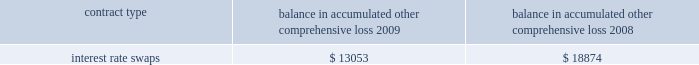The table below represents unrealized losses related to derivative amounts included in 201caccumulated other comprehensive loss 201d for the years ended december 31 , ( in thousands ) : balance in accumulated other comprehensive loss .
Note 9 2013 fair value measurements the company uses the fair value hierarchy , which prioritizes the inputs used to measure the fair value of certain of its financial instruments .
The hierarchy gives the highest priority to unadjusted quoted prices in active markets for identical assets or liabilities ( level 1 measurement ) and the lowest priority to unobservable inputs ( level 3 measurement ) .
The three levels of the fair value hierarchy are set forth below : 2022 level 1 2013 quoted prices are available in active markets for identical assets or liabilities as of the reporting date .
Active markets are those in which transactions for the asset or liability occur in sufficient frequency and volume to provide pricing information on an ongoing basis .
2022 level 2 2013 pricing inputs are other than quoted prices in active markets included in level 1 , which are either directly or indirectly observable as of the reporting date .
Level 2 includes those financial instruments that are valued using models or other valuation methodologies .
These models are primarily industry-standard models that consider various assumptions , including time value , volatility factors , and current market and contractual prices for the underlying instruments , as well as other relevant economic measures .
Substantially all of these assumptions are observable in the marketplace throughout the full term of the instrument , can be derived from observable data or are supported by observable levels at which transactions are executed in the marketplace .
2022 level 3 2013 pricing inputs include significant inputs that are generally less observable from objective sources .
These inputs may be used with internally developed methodologies that result in management 2019s best estimate of fair value from the perspective of a market participant .
The fair value of the interest rate swap transactions are based on the discounted net present value of the swap using third party quotes ( level 2 ) .
Changes in fair market value are recorded in other comprehensive income ( loss ) , and changes resulting from ineffectiveness are recorded in current earnings .
Assets and liabilities measured at fair value are based on one or more of three valuation techniques .
The three valuation techniques are identified in the table below and are as follows : a ) market approach 2013 prices and other relevant information generated by market transactions involving identical or comparable assets or liabilities b ) cost approach 2013 amount that would be required to replace the service capacity of an asset ( replacement cost ) c ) income approach 2013 techniques to convert future amounts to a single present amount based on market expectations ( including present value techniques , option-pricing and excess earnings models ) .
For unrealized losses related to derivative amounts included in 201caccumulated other comprehensive loss 201d for the years ended december 31 , ( in thousands ) , what was the total balance in accumulated other comprehensive loss for the two years combined? 
Computations: table_sum(interest rate swaps, none)
Answer: 31927.0. The table below represents unrealized losses related to derivative amounts included in 201caccumulated other comprehensive loss 201d for the years ended december 31 , ( in thousands ) : balance in accumulated other comprehensive loss .
Note 9 2013 fair value measurements the company uses the fair value hierarchy , which prioritizes the inputs used to measure the fair value of certain of its financial instruments .
The hierarchy gives the highest priority to unadjusted quoted prices in active markets for identical assets or liabilities ( level 1 measurement ) and the lowest priority to unobservable inputs ( level 3 measurement ) .
The three levels of the fair value hierarchy are set forth below : 2022 level 1 2013 quoted prices are available in active markets for identical assets or liabilities as of the reporting date .
Active markets are those in which transactions for the asset or liability occur in sufficient frequency and volume to provide pricing information on an ongoing basis .
2022 level 2 2013 pricing inputs are other than quoted prices in active markets included in level 1 , which are either directly or indirectly observable as of the reporting date .
Level 2 includes those financial instruments that are valued using models or other valuation methodologies .
These models are primarily industry-standard models that consider various assumptions , including time value , volatility factors , and current market and contractual prices for the underlying instruments , as well as other relevant economic measures .
Substantially all of these assumptions are observable in the marketplace throughout the full term of the instrument , can be derived from observable data or are supported by observable levels at which transactions are executed in the marketplace .
2022 level 3 2013 pricing inputs include significant inputs that are generally less observable from objective sources .
These inputs may be used with internally developed methodologies that result in management 2019s best estimate of fair value from the perspective of a market participant .
The fair value of the interest rate swap transactions are based on the discounted net present value of the swap using third party quotes ( level 2 ) .
Changes in fair market value are recorded in other comprehensive income ( loss ) , and changes resulting from ineffectiveness are recorded in current earnings .
Assets and liabilities measured at fair value are based on one or more of three valuation techniques .
The three valuation techniques are identified in the table below and are as follows : a ) market approach 2013 prices and other relevant information generated by market transactions involving identical or comparable assets or liabilities b ) cost approach 2013 amount that would be required to replace the service capacity of an asset ( replacement cost ) c ) income approach 2013 techniques to convert future amounts to a single present amount based on market expectations ( including present value techniques , option-pricing and excess earnings models ) .
What is the percentage change in the balance of accumulated other comprehensive loss from 2008 to 2009? 
Computations: ((13053 - 18874) / 18874)
Answer: -0.30841. 